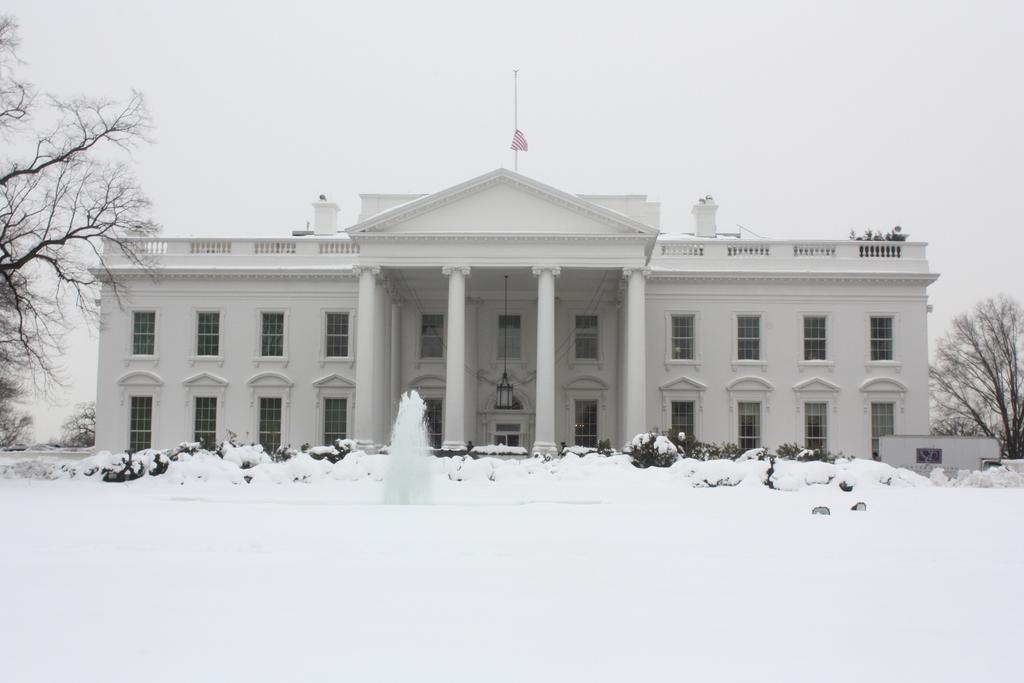Can you describe this image briefly? In this picture we can see trees, snow, flag, building with windows and in the background we can see the sky. 